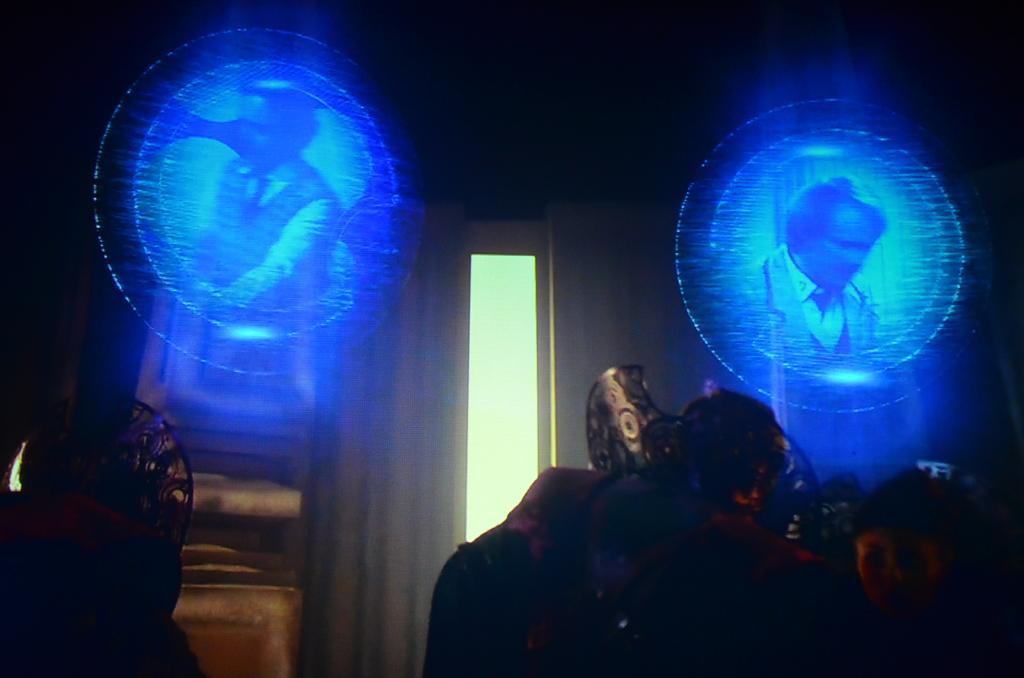Describe this image in one or two sentences. Here we can see a sculpture and a person. There are screens and there is a dark background. 